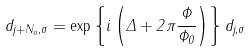<formula> <loc_0><loc_0><loc_500><loc_500>d _ { j + N _ { a } , \sigma } = \exp \left \{ i \left ( \Delta + 2 \pi \frac { \Phi } { \Phi _ { 0 } } \right ) \right \} d _ { j , \sigma }</formula> 